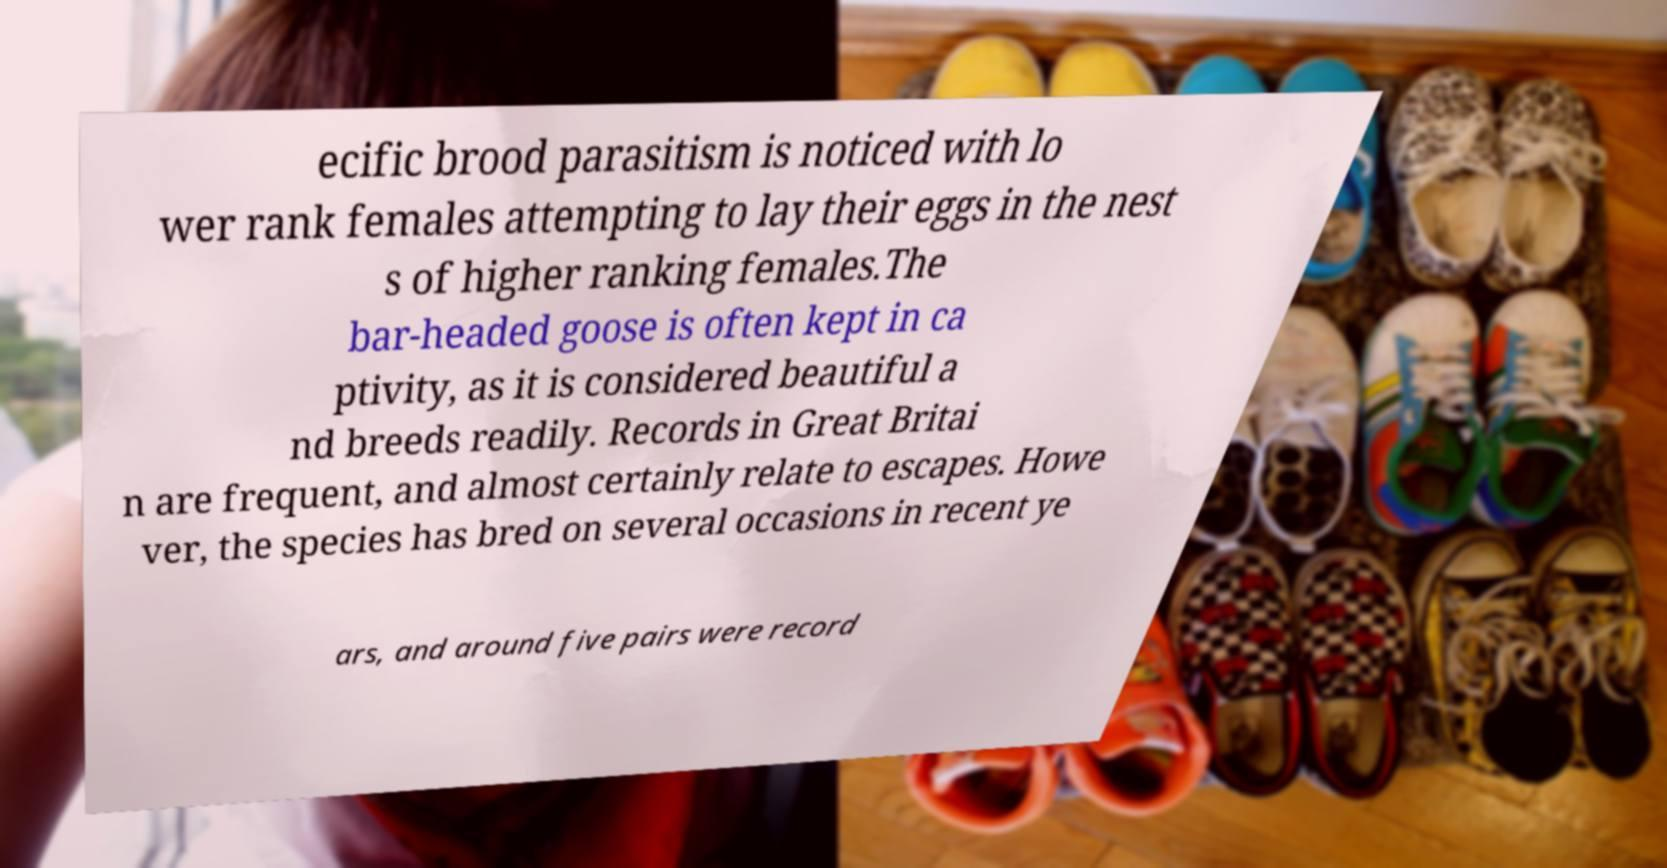Please read and relay the text visible in this image. What does it say? ecific brood parasitism is noticed with lo wer rank females attempting to lay their eggs in the nest s of higher ranking females.The bar-headed goose is often kept in ca ptivity, as it is considered beautiful a nd breeds readily. Records in Great Britai n are frequent, and almost certainly relate to escapes. Howe ver, the species has bred on several occasions in recent ye ars, and around five pairs were record 